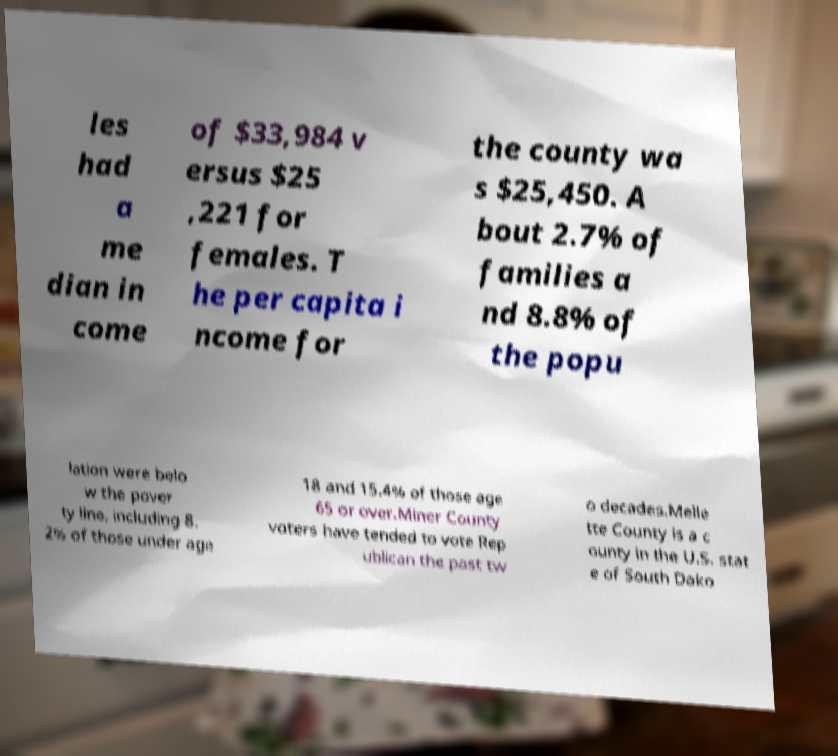Can you accurately transcribe the text from the provided image for me? les had a me dian in come of $33,984 v ersus $25 ,221 for females. T he per capita i ncome for the county wa s $25,450. A bout 2.7% of families a nd 8.8% of the popu lation were belo w the pover ty line, including 8. 2% of those under age 18 and 15.4% of those age 65 or over.Miner County voters have tended to vote Rep ublican the past tw o decades.Melle tte County is a c ounty in the U.S. stat e of South Dako 